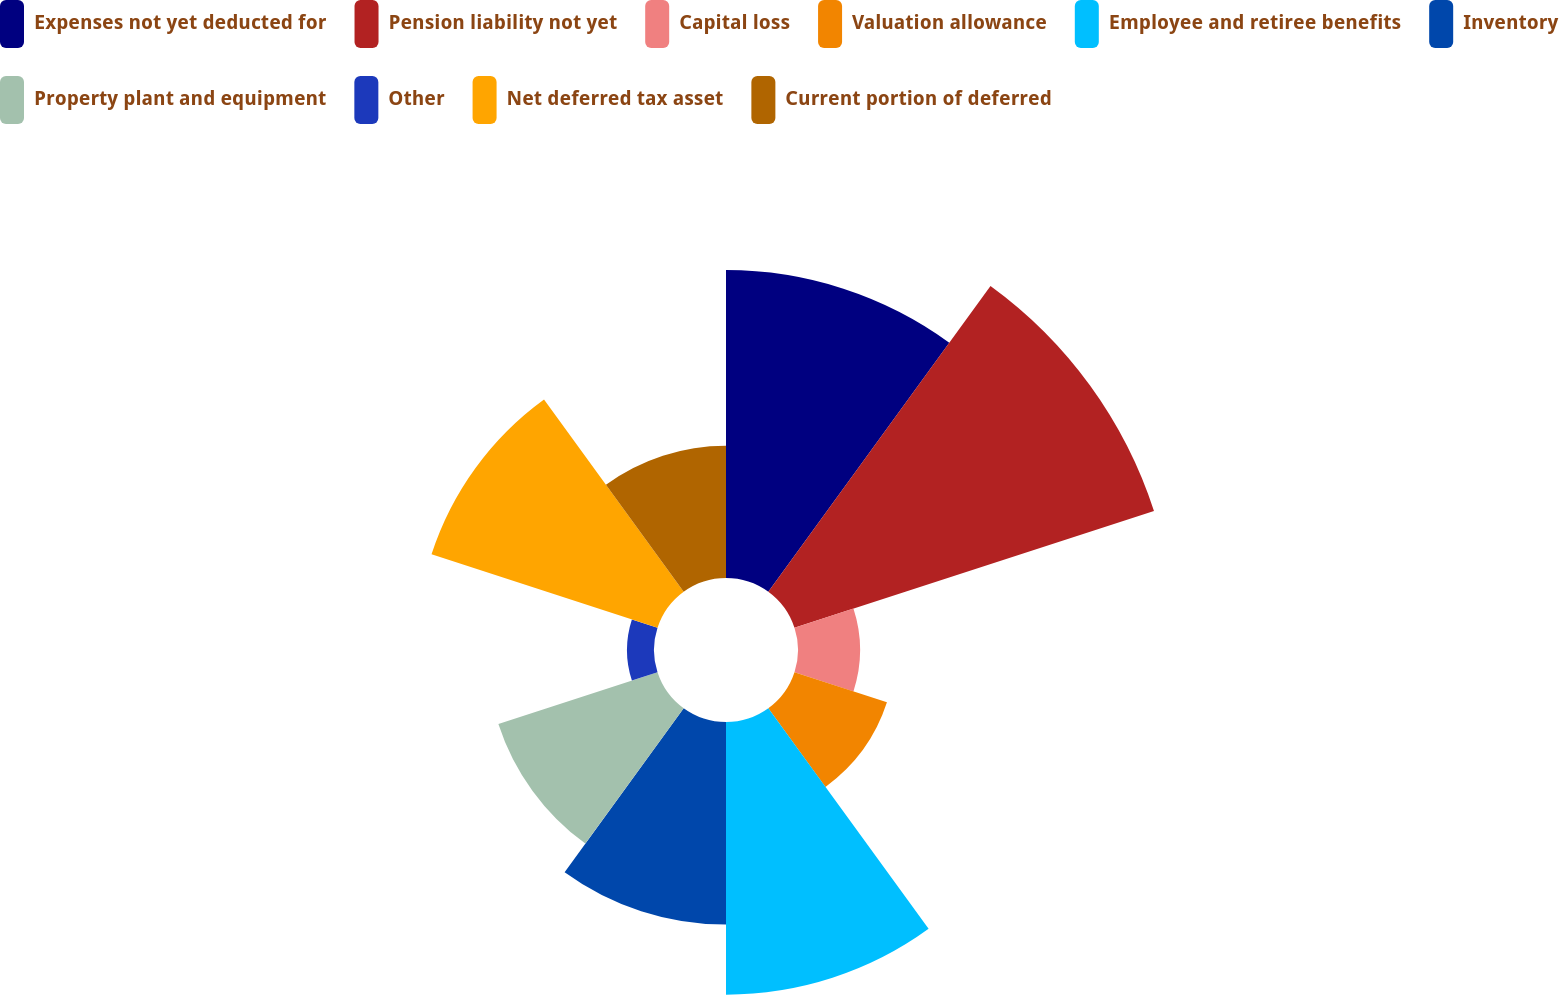Convert chart. <chart><loc_0><loc_0><loc_500><loc_500><pie_chart><fcel>Expenses not yet deducted for<fcel>Pension liability not yet<fcel>Capital loss<fcel>Valuation allowance<fcel>Employee and retiree benefits<fcel>Inventory<fcel>Property plant and equipment<fcel>Other<fcel>Net deferred tax asset<fcel>Current portion of deferred<nl><fcel>16.34%<fcel>20.06%<fcel>3.29%<fcel>5.16%<fcel>14.47%<fcel>10.75%<fcel>8.88%<fcel>1.43%<fcel>12.61%<fcel>7.02%<nl></chart> 